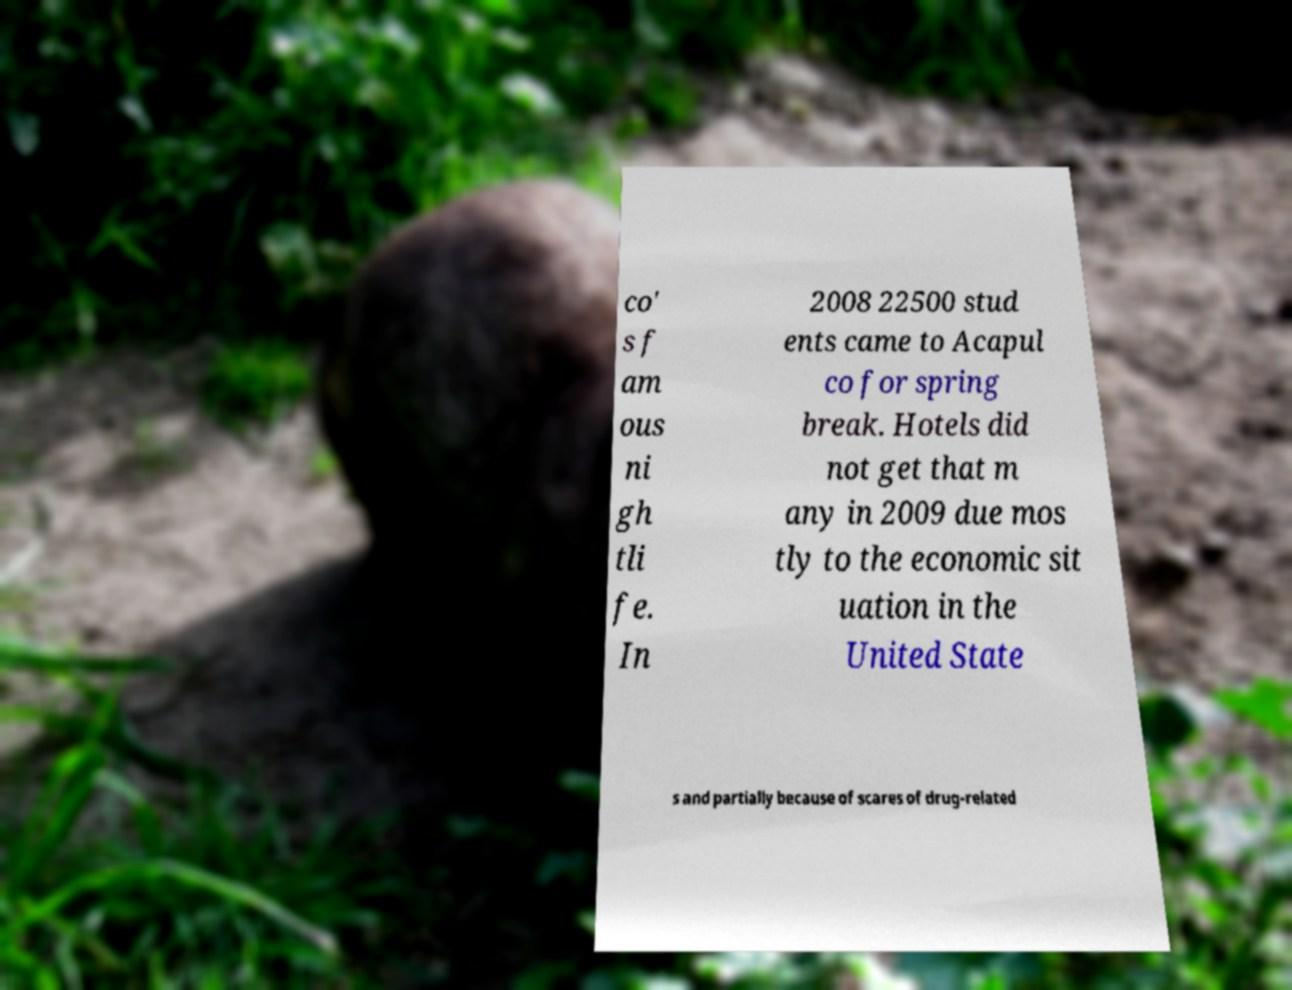What messages or text are displayed in this image? I need them in a readable, typed format. co' s f am ous ni gh tli fe. In 2008 22500 stud ents came to Acapul co for spring break. Hotels did not get that m any in 2009 due mos tly to the economic sit uation in the United State s and partially because of scares of drug-related 